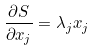<formula> <loc_0><loc_0><loc_500><loc_500>\frac { \partial S } { \partial x _ { j } } = \lambda _ { j } x _ { j }</formula> 